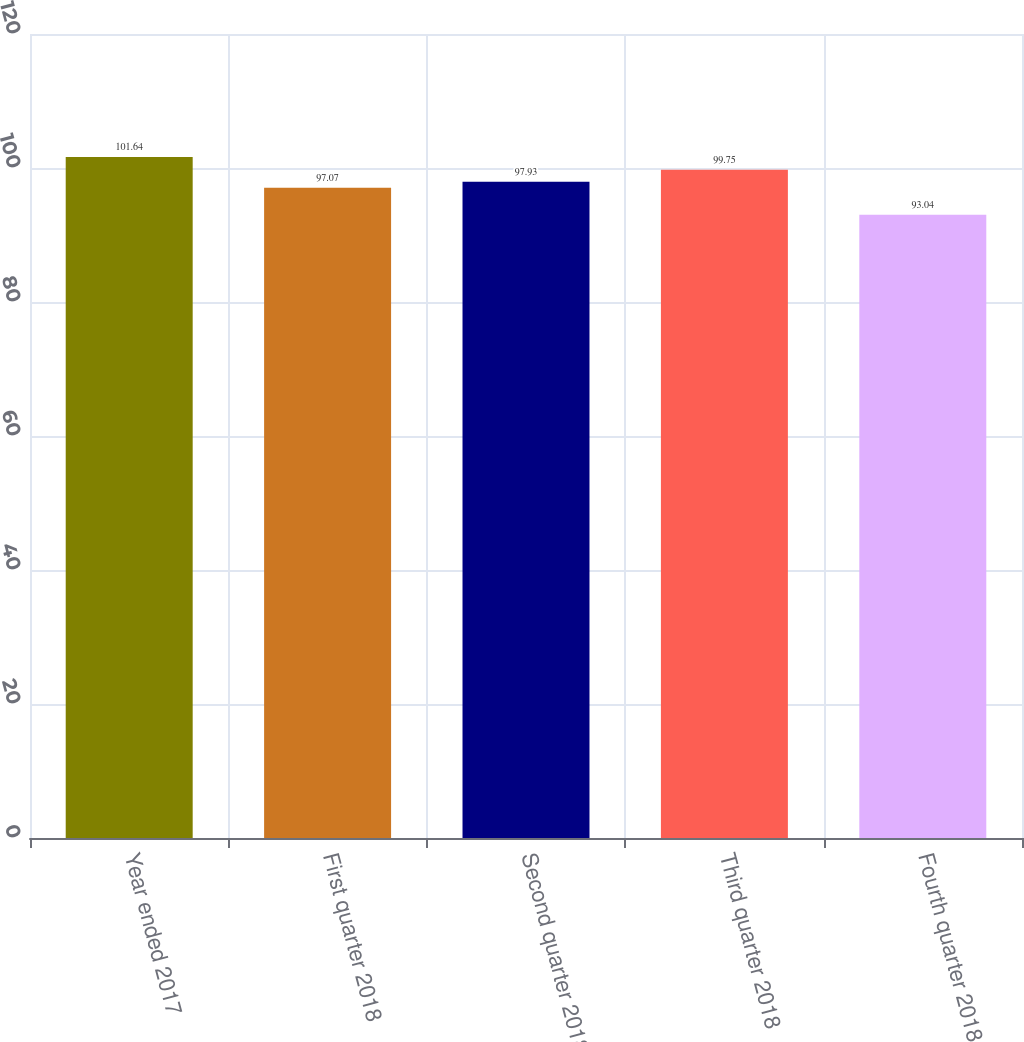Convert chart to OTSL. <chart><loc_0><loc_0><loc_500><loc_500><bar_chart><fcel>Year ended 2017<fcel>First quarter 2018<fcel>Second quarter 2018<fcel>Third quarter 2018<fcel>Fourth quarter 2018<nl><fcel>101.64<fcel>97.07<fcel>97.93<fcel>99.75<fcel>93.04<nl></chart> 